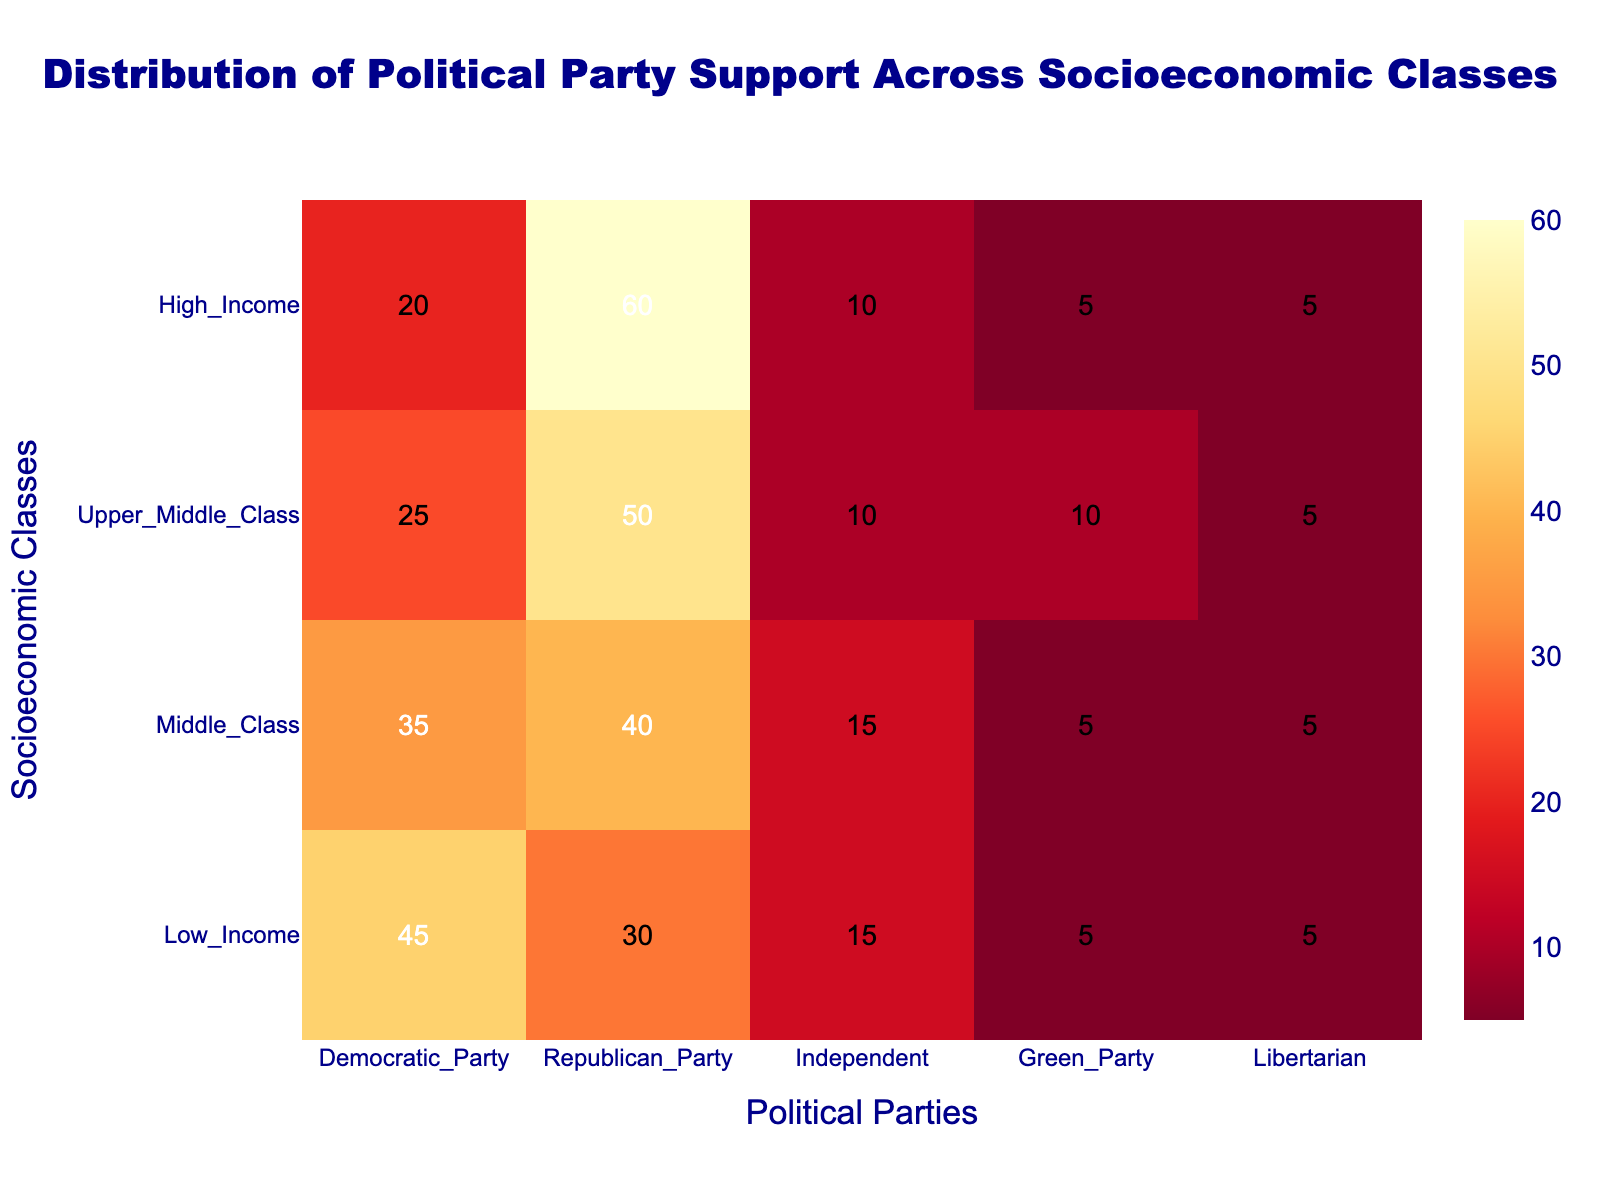what is the title of the heatmap? The title is located at the top center of the figure in dark blue, with a larger font size. It reads "Distribution of Political Party Support Across Socioeconomic Classes".
Answer: Distribution of Political Party Support Across Socioeconomic Classes Which socioeconomic class shows the highest support for the Republican Party? By observing the heatmap, it's clear that the darkest cell for the Republican Party column is in the High Income row. This indicates the highest support.
Answer: High Income What is the difference in support for the Democratic Party between Low Income and High Income classes? The Democratic Party support for Low Income class is 45, and for High Income class is 20. Subtracting these: 45 - 20 = 25.
Answer: 25 Which party has consistent support (same percentage) across all socioeconomic classes? By observing each column, only the Libertarian Party column shows a consistent value of 5 across all rows.
Answer: Libertarian How many socioeconomic classes are represented in the heatmap? Counting the unique labels on the y-axis, it shows four different socioeconomic classes: Low Income, Middle Class, Upper Middle Class, and High Income.
Answer: Four Which socioeconomic class has the least support for the independent party? The independent party section shows the lowest value in the Upper Middle Class row with 10%.
Answer: Upper Middle Class What is the average support for the Green Party across all socioeconomic classes? Adding the Green Party support values (5+5+10+5) gives 25. Dividing by four classes: 25 / 4 = 6.25.
Answer: 6.25 Compare the Democratic Party support for Middle Class and Upper Middle Class. The Democratic Party support for Middle Class is 35, while for Upper Middle Class it is 25, indicating higher support among the Middle Class.
Answer: Middle Class Which party shows the most variation in support across socioeconomic classes? Looking at the differences in percentages for each party across classes, the Republican Party varies the most from 30 to 60.
Answer: Republican Party 